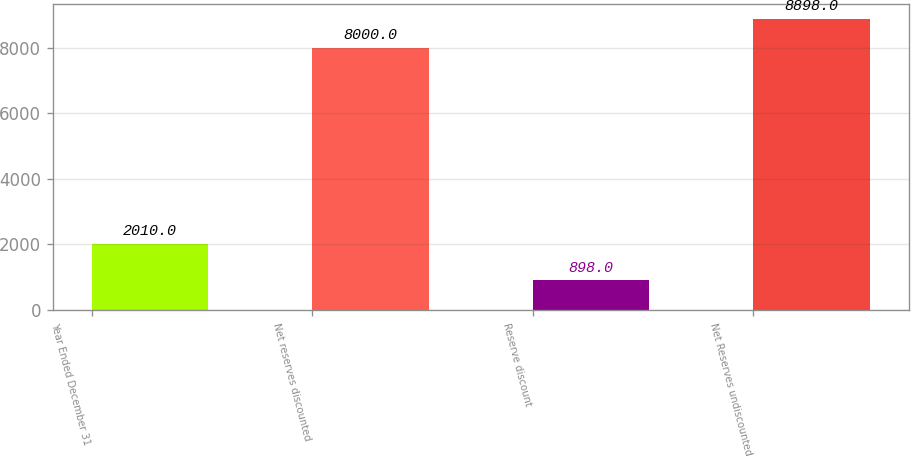Convert chart. <chart><loc_0><loc_0><loc_500><loc_500><bar_chart><fcel>Year Ended December 31<fcel>Net reserves discounted<fcel>Reserve discount<fcel>Net Reserves undiscounted<nl><fcel>2010<fcel>8000<fcel>898<fcel>8898<nl></chart> 